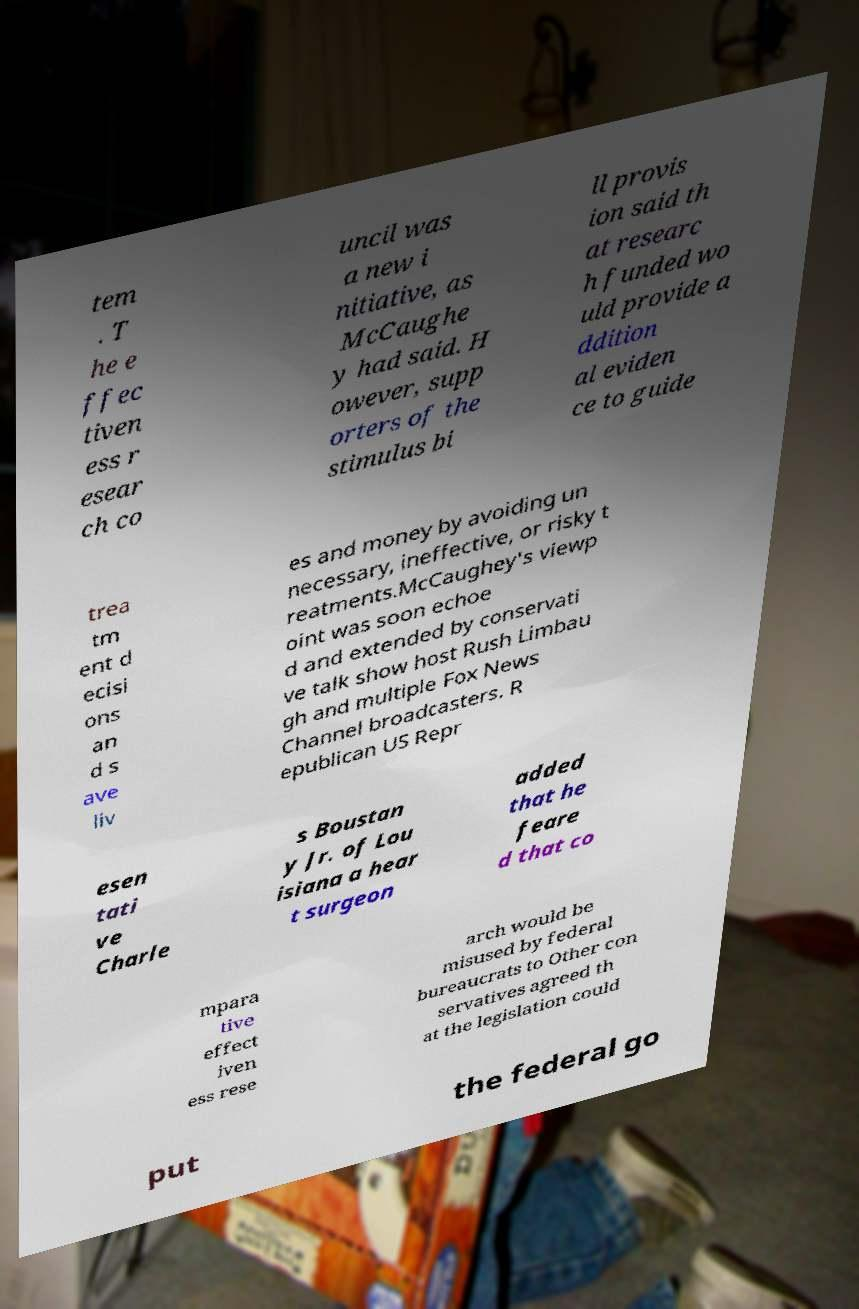Please read and relay the text visible in this image. What does it say? tem . T he e ffec tiven ess r esear ch co uncil was a new i nitiative, as McCaughe y had said. H owever, supp orters of the stimulus bi ll provis ion said th at researc h funded wo uld provide a ddition al eviden ce to guide trea tm ent d ecisi ons an d s ave liv es and money by avoiding un necessary, ineffective, or risky t reatments.McCaughey's viewp oint was soon echoe d and extended by conservati ve talk show host Rush Limbau gh and multiple Fox News Channel broadcasters. R epublican US Repr esen tati ve Charle s Boustan y Jr. of Lou isiana a hear t surgeon added that he feare d that co mpara tive effect iven ess rese arch would be misused by federal bureaucrats to Other con servatives agreed th at the legislation could put the federal go 